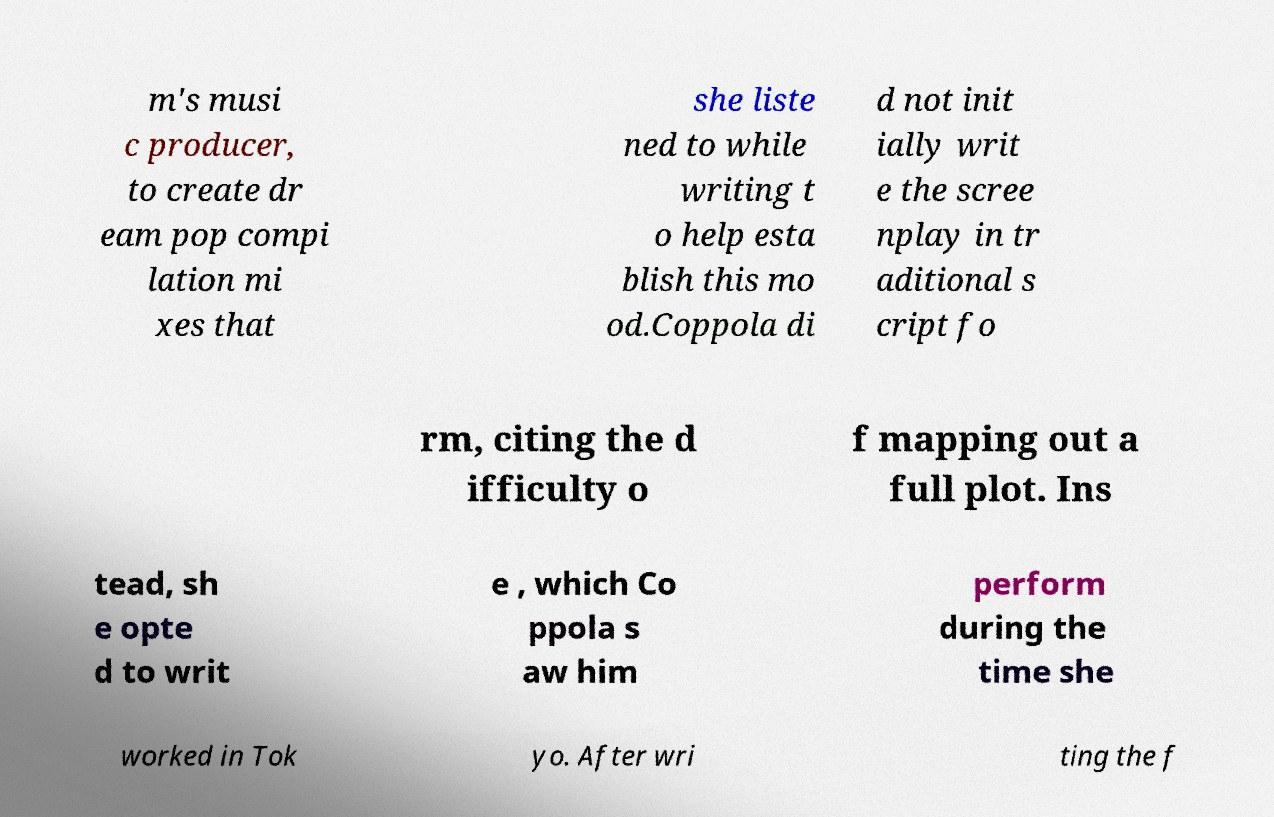For documentation purposes, I need the text within this image transcribed. Could you provide that? m's musi c producer, to create dr eam pop compi lation mi xes that she liste ned to while writing t o help esta blish this mo od.Coppola di d not init ially writ e the scree nplay in tr aditional s cript fo rm, citing the d ifficulty o f mapping out a full plot. Ins tead, sh e opte d to writ e , which Co ppola s aw him perform during the time she worked in Tok yo. After wri ting the f 